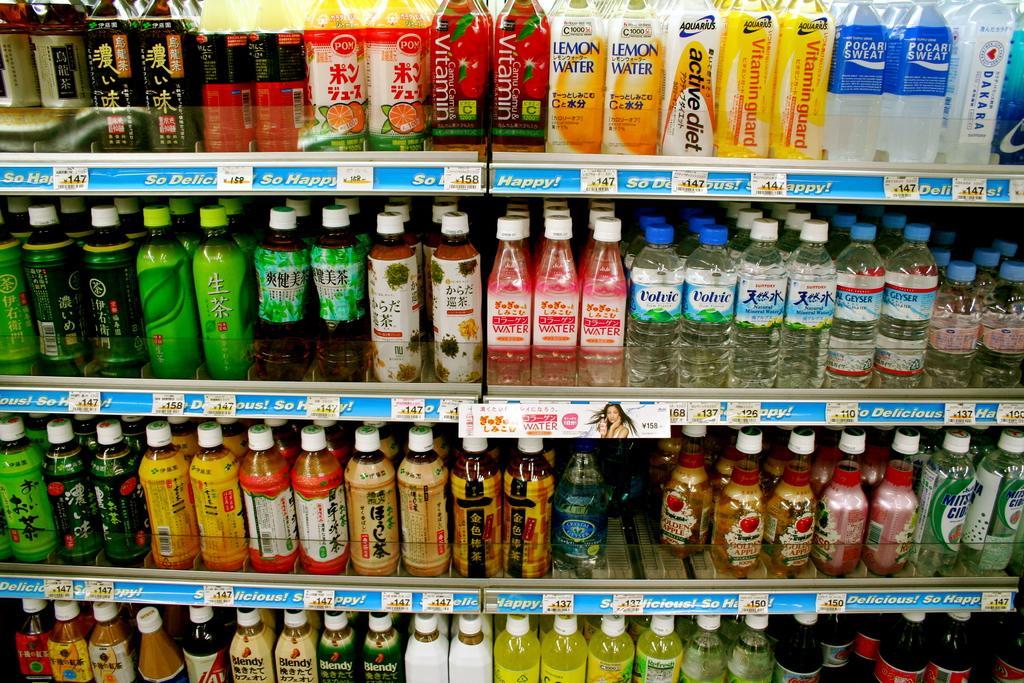Please provide a concise description of this image. There are many racks. On this there are different varieties of bottles are kept. And there are labels on the bottle. 